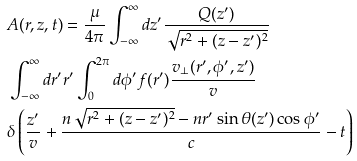<formula> <loc_0><loc_0><loc_500><loc_500>& A ( r , z , t ) = \frac { \mu } { 4 \pi } \int _ { - \infty } ^ { \infty } d z ^ { \prime } \frac { Q ( z ^ { \prime } ) } { \sqrt { r ^ { 2 } + ( z - z ^ { \prime } ) ^ { 2 } } } \\ & \int _ { - \infty } ^ { \infty } d r ^ { \prime } r ^ { \prime } \int _ { 0 } ^ { 2 \pi } d \phi ^ { \prime } f ( r ^ { \prime } ) \frac { v _ { \perp } ( r ^ { \prime } , \phi ^ { \prime } , z ^ { \prime } ) } { v } \\ & \delta \left ( \frac { z ^ { \prime } } { v } + \frac { n \sqrt { r ^ { 2 } + ( z - z ^ { \prime } ) ^ { 2 } } - n r ^ { \prime } \sin \theta ( z ^ { \prime } ) \cos \phi ^ { \prime } } { c } - t \right )</formula> 